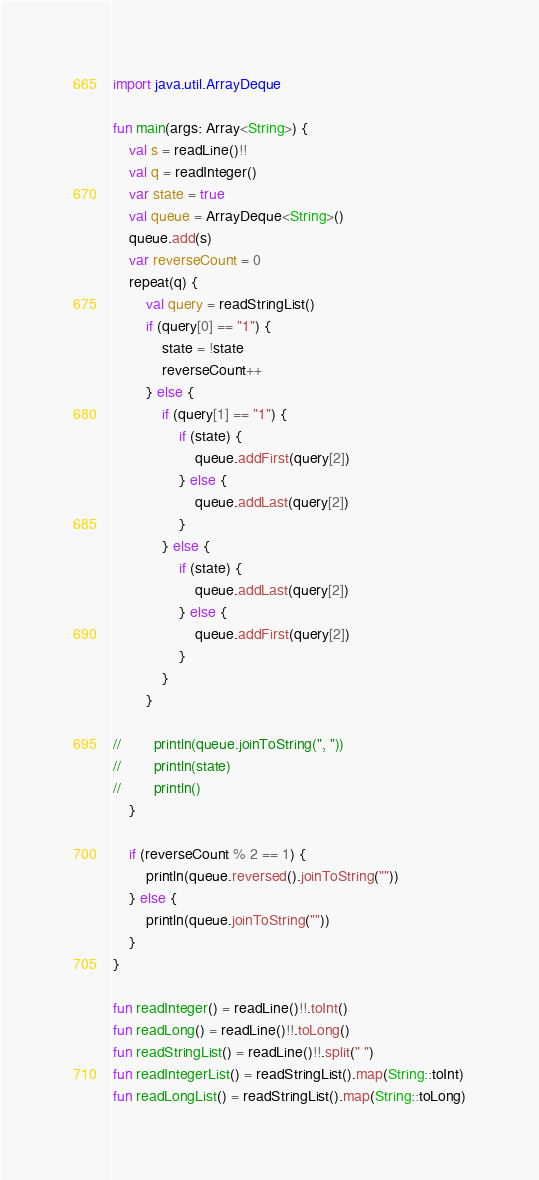<code> <loc_0><loc_0><loc_500><loc_500><_Kotlin_>import java.util.ArrayDeque

fun main(args: Array<String>) {
    val s = readLine()!!
    val q = readInteger()
    var state = true
    val queue = ArrayDeque<String>()
    queue.add(s)
    var reverseCount = 0
    repeat(q) {
        val query = readStringList()
        if (query[0] == "1") {
            state = !state
            reverseCount++
        } else {
            if (query[1] == "1") {
                if (state) {
                    queue.addFirst(query[2])
                } else {
                    queue.addLast(query[2])
                }
            } else {
                if (state) {
                    queue.addLast(query[2])
                } else {
                    queue.addFirst(query[2])
                }
            }
        }

//        println(queue.joinToString(", "))
//        println(state)
//        println()
    }

    if (reverseCount % 2 == 1) {
        println(queue.reversed().joinToString(""))
    } else {
        println(queue.joinToString(""))
    }
}

fun readInteger() = readLine()!!.toInt()
fun readLong() = readLine()!!.toLong()
fun readStringList() = readLine()!!.split(" ")
fun readIntegerList() = readStringList().map(String::toInt)
fun readLongList() = readStringList().map(String::toLong)
</code> 